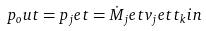<formula> <loc_0><loc_0><loc_500><loc_500>p _ { o } u t = p _ { j } e t = \dot { M } _ { j } e t v _ { j } e t t _ { k } i n</formula> 